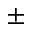Convert formula to latex. <formula><loc_0><loc_0><loc_500><loc_500>\pm</formula> 